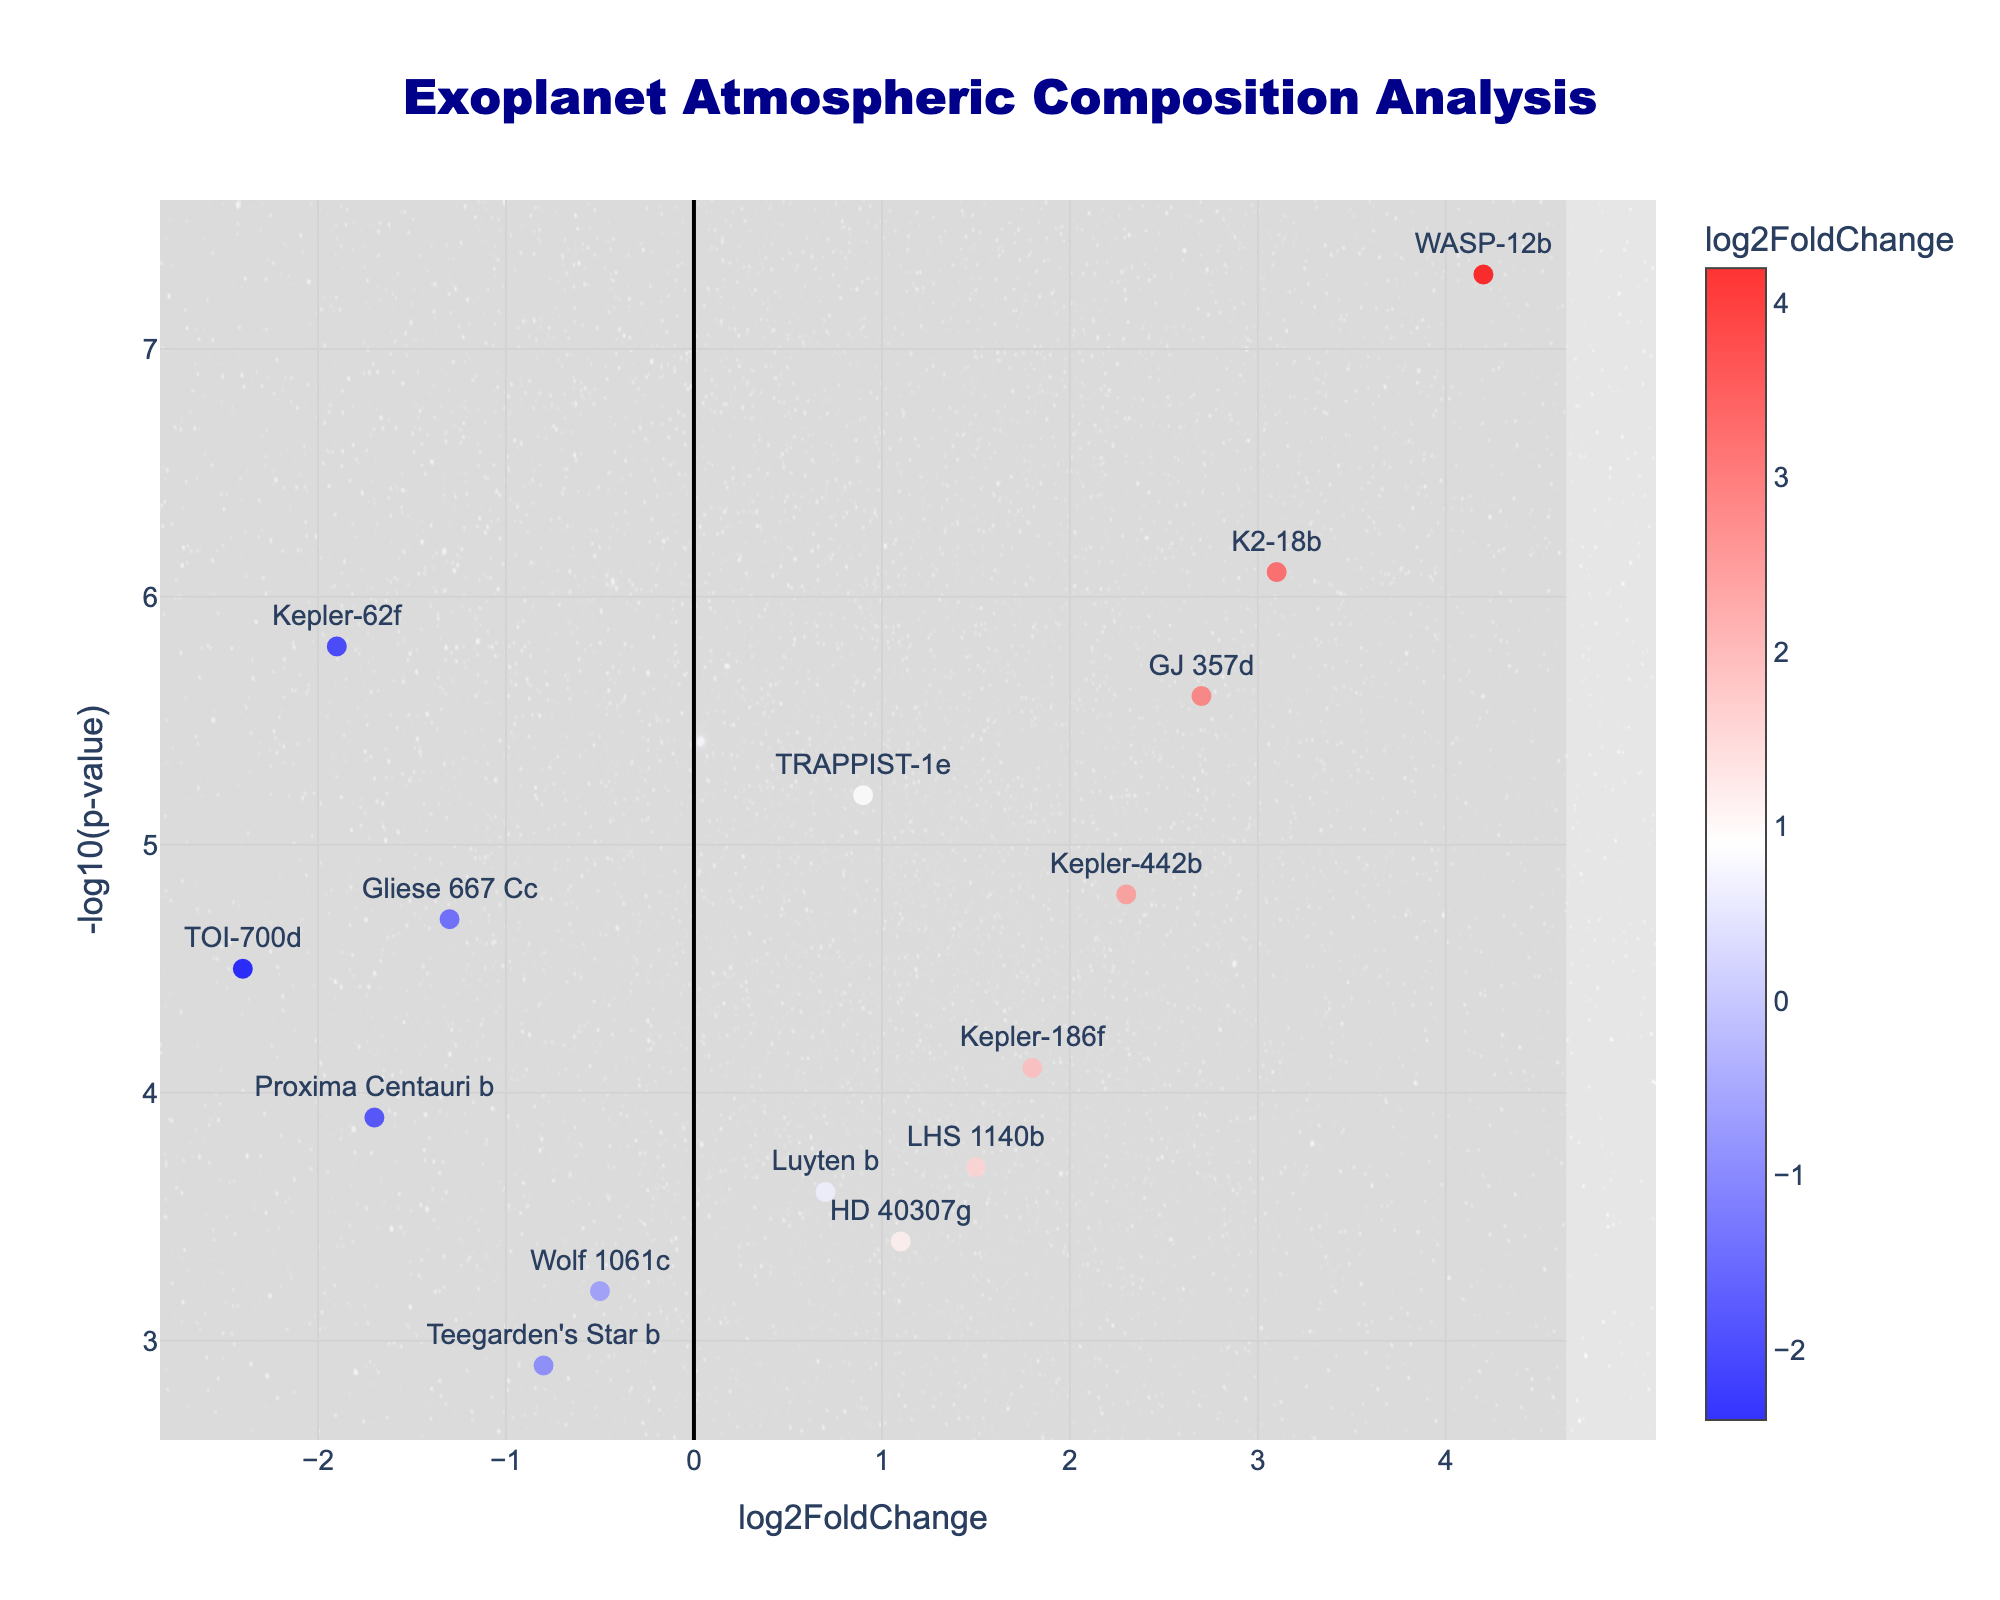Which exoplanet has the highest log2FoldChange? By looking at the x-axis, we see that WASP-12b is positioned furthest to the right, indicating it has the highest log2FoldChange.
Answer: WASP-12b What's the title of the plot? The title is located at the top center of the plot.
Answer: Exoplanet Atmospheric Composition Analysis How many exoplanets have a negative log2FoldChange? For a log2FoldChange less than 0, we count the points positioned to the left of the y-axis. They are Proxima Centauri b, TOI-700d, Teegarden's Star b, Gliese 667 Cc, Wolf 1061c, and Kepler-62f.
Answer: 6 Which exoplanet has the highest -log10(p-value) and what is its log2FoldChange? By looking at both the x and y axes, K2-18b has the highest -log10(p-value) located at the top of the y-axis with a log2FoldChange of 3.1.
Answer: K2-18b, 3.1 What is the log2FoldChange range for the exoplanets plotted? The minimum log2FoldChange is around -2.4 (TOI-700d) and the maximum is around 4.2 (WASP-12b).
Answer: -2.4 to 4.2 Which exoplanets are situated around the center of the plot? Analyzing the points near the center (log2FoldChange around 0), we see TRAPPIST-1e, Teegarden's Star b, and Wolf 1061c are the nearest.
Answer: TRAPPIST-1e, Teegarden's Star b, Wolf 1061c Which exoplanet shows the most significant p-value among those with a negative log2FoldChange? For the planets on the left side of zero, the one with the highest -log10(p-value) is Kepler-62f.
Answer: Kepler-62f How does the atmospheric composition of Kepler-442b compare to Gliese 667 Cc in terms of fold change and significance? Kepler-442b has a log2FoldChange of 2.3 and -log10(p-value) of 4.8, while Gliese 667 Cc has a log2FoldChange of -1.3 and -log10(p-value) of 4.7. Kepler-442b has a higher fold change and nearly the same p-value significance compared to Gliese 667 Cc.
Answer: Higher fold change, similar significance What background image is used in the plot, and why might it be relevant? The plot includes an image depicting a cosmic background, seen in the background layer. This adds thematic relevance to the topic of exoplanets and outer space.
Answer: Cosmic background image Which exoplanet is closest to having a log2FoldChange of zero and how significant is its p-value? TRAPPIST-1e is closest to zero with a log2FoldChange of 0.9. Regarding its p-value, it has a -log10(p-value) of 5.2.
Answer: TRAPPIST-1e, 5.2 